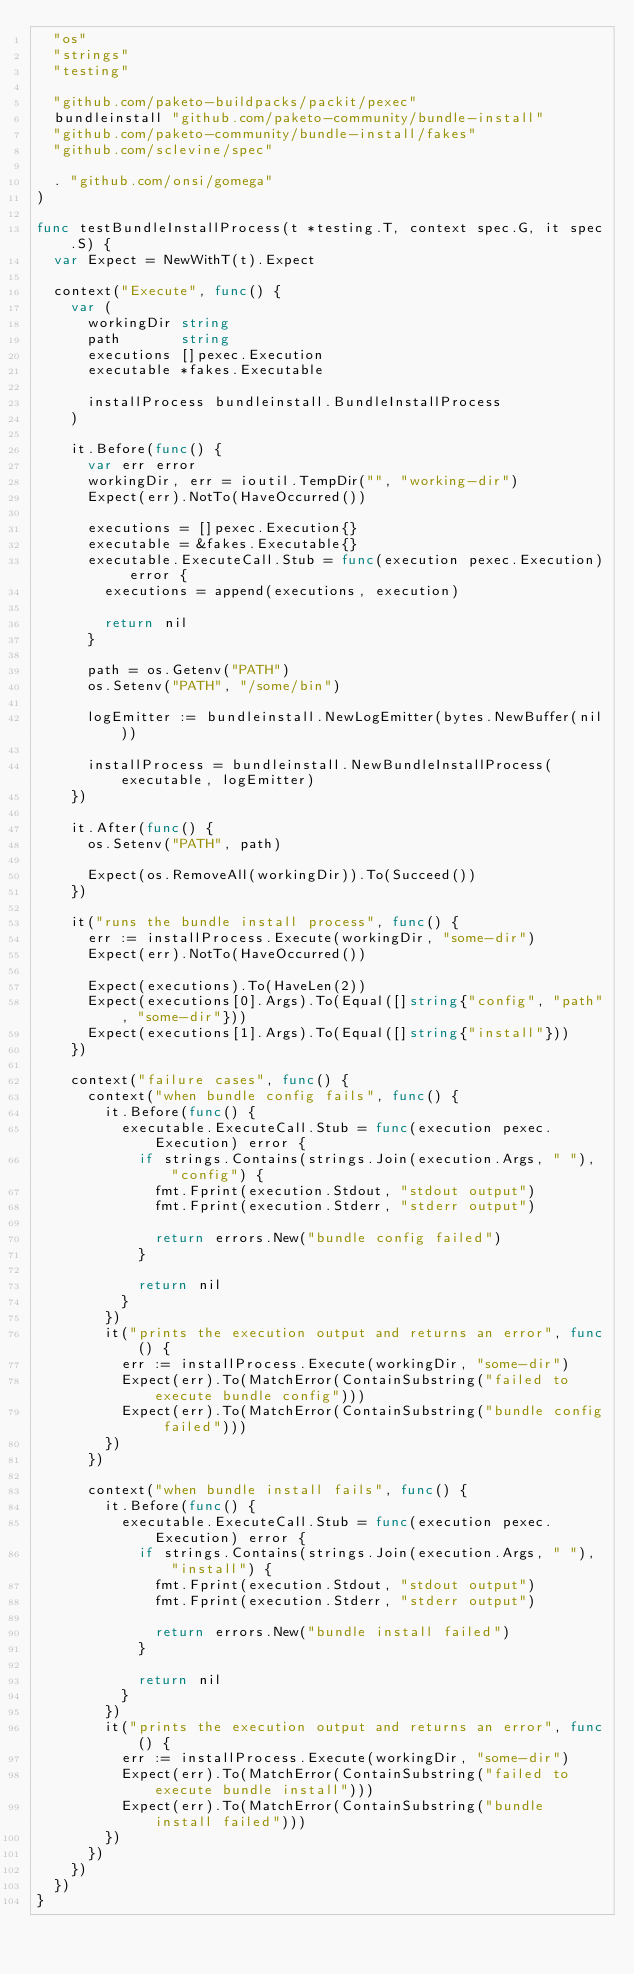Convert code to text. <code><loc_0><loc_0><loc_500><loc_500><_Go_>	"os"
	"strings"
	"testing"

	"github.com/paketo-buildpacks/packit/pexec"
	bundleinstall "github.com/paketo-community/bundle-install"
	"github.com/paketo-community/bundle-install/fakes"
	"github.com/sclevine/spec"

	. "github.com/onsi/gomega"
)

func testBundleInstallProcess(t *testing.T, context spec.G, it spec.S) {
	var Expect = NewWithT(t).Expect

	context("Execute", func() {
		var (
			workingDir string
			path       string
			executions []pexec.Execution
			executable *fakes.Executable

			installProcess bundleinstall.BundleInstallProcess
		)

		it.Before(func() {
			var err error
			workingDir, err = ioutil.TempDir("", "working-dir")
			Expect(err).NotTo(HaveOccurred())

			executions = []pexec.Execution{}
			executable = &fakes.Executable{}
			executable.ExecuteCall.Stub = func(execution pexec.Execution) error {
				executions = append(executions, execution)

				return nil
			}

			path = os.Getenv("PATH")
			os.Setenv("PATH", "/some/bin")

			logEmitter := bundleinstall.NewLogEmitter(bytes.NewBuffer(nil))

			installProcess = bundleinstall.NewBundleInstallProcess(executable, logEmitter)
		})

		it.After(func() {
			os.Setenv("PATH", path)

			Expect(os.RemoveAll(workingDir)).To(Succeed())
		})

		it("runs the bundle install process", func() {
			err := installProcess.Execute(workingDir, "some-dir")
			Expect(err).NotTo(HaveOccurred())

			Expect(executions).To(HaveLen(2))
			Expect(executions[0].Args).To(Equal([]string{"config", "path", "some-dir"}))
			Expect(executions[1].Args).To(Equal([]string{"install"}))
		})

		context("failure cases", func() {
			context("when bundle config fails", func() {
				it.Before(func() {
					executable.ExecuteCall.Stub = func(execution pexec.Execution) error {
						if strings.Contains(strings.Join(execution.Args, " "), "config") {
							fmt.Fprint(execution.Stdout, "stdout output")
							fmt.Fprint(execution.Stderr, "stderr output")

							return errors.New("bundle config failed")
						}

						return nil
					}
				})
				it("prints the execution output and returns an error", func() {
					err := installProcess.Execute(workingDir, "some-dir")
					Expect(err).To(MatchError(ContainSubstring("failed to execute bundle config")))
					Expect(err).To(MatchError(ContainSubstring("bundle config failed")))
				})
			})

			context("when bundle install fails", func() {
				it.Before(func() {
					executable.ExecuteCall.Stub = func(execution pexec.Execution) error {
						if strings.Contains(strings.Join(execution.Args, " "), "install") {
							fmt.Fprint(execution.Stdout, "stdout output")
							fmt.Fprint(execution.Stderr, "stderr output")

							return errors.New("bundle install failed")
						}

						return nil
					}
				})
				it("prints the execution output and returns an error", func() {
					err := installProcess.Execute(workingDir, "some-dir")
					Expect(err).To(MatchError(ContainSubstring("failed to execute bundle install")))
					Expect(err).To(MatchError(ContainSubstring("bundle install failed")))
				})
			})
		})
	})
}
</code> 